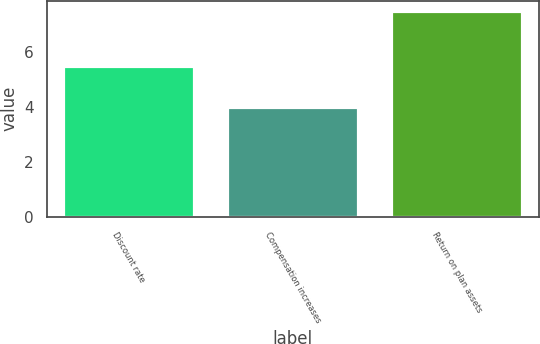Convert chart. <chart><loc_0><loc_0><loc_500><loc_500><bar_chart><fcel>Discount rate<fcel>Compensation increases<fcel>Return on plan assets<nl><fcel>5.5<fcel>4<fcel>7.5<nl></chart> 